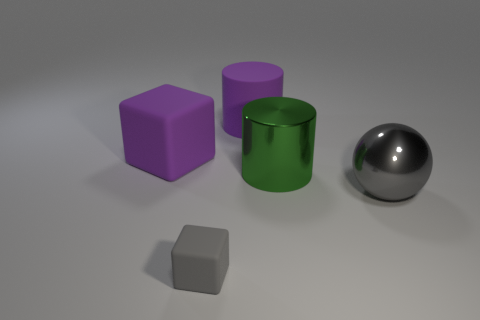Add 4 shiny things. How many objects exist? 9 Subtract 1 cubes. How many cubes are left? 1 Subtract all gray cubes. Subtract all cyan spheres. How many cubes are left? 1 Subtract all purple cubes. How many brown balls are left? 0 Subtract all big purple shiny spheres. Subtract all big green metallic objects. How many objects are left? 4 Add 2 big gray metallic things. How many big gray metallic things are left? 3 Add 1 big cyan shiny objects. How many big cyan shiny objects exist? 1 Subtract 1 purple cylinders. How many objects are left? 4 Subtract all balls. How many objects are left? 4 